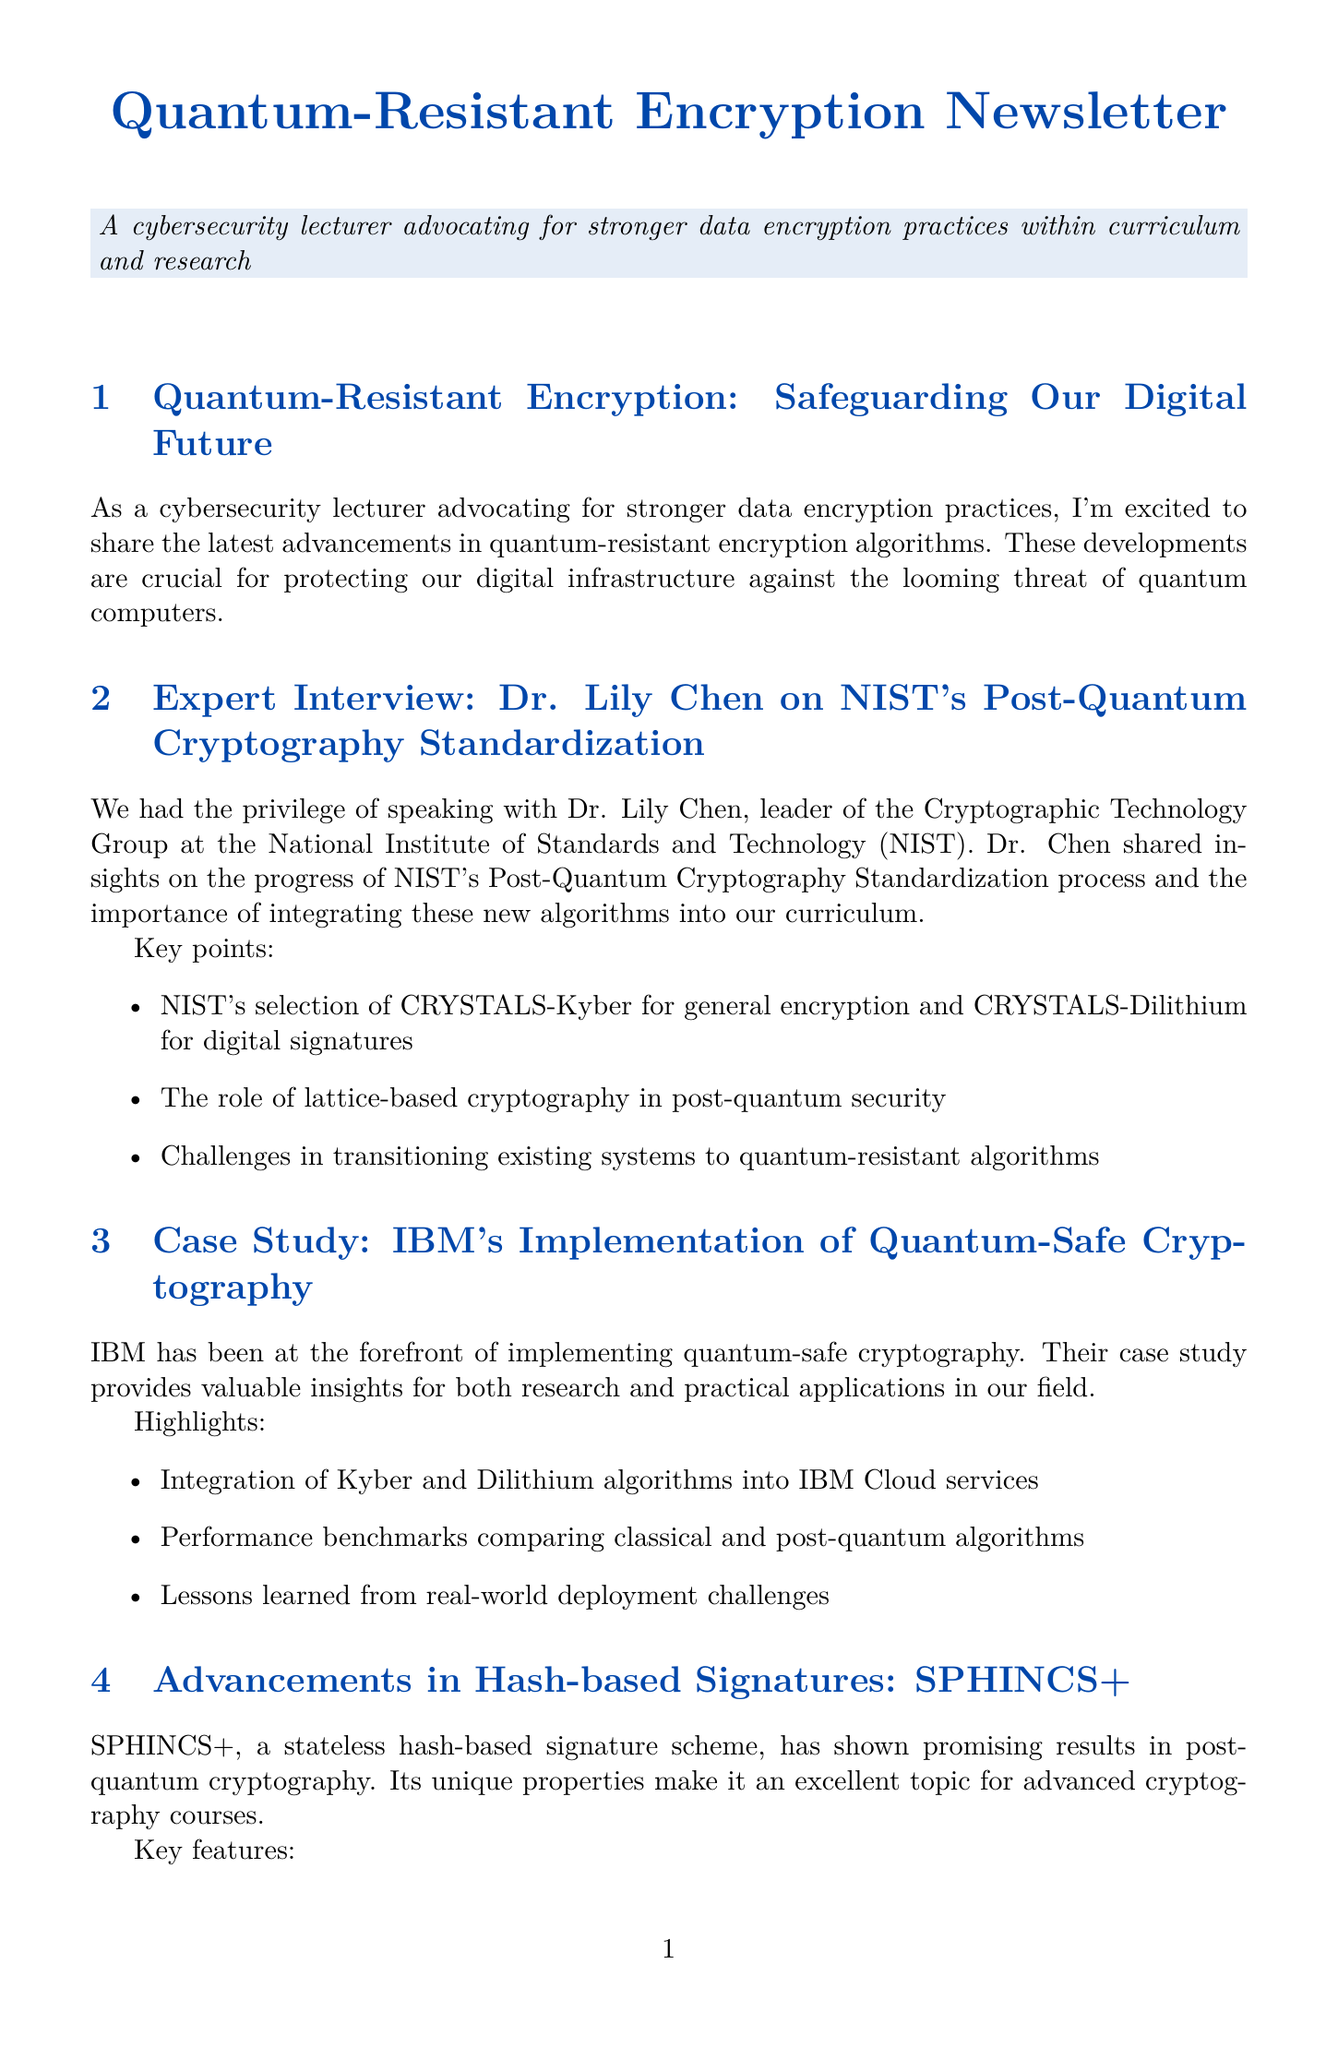What is the title of the first section? The title of the first section is explicitly stated in the document.
Answer: Quantum-Resistant Encryption: Safeguarding Our Digital Future Who is the expert interviewed in the newsletter? The interview section mentions the name of the expert who provided insights on post-quantum cryptography.
Answer: Dr. Lily Chen What algorithm did NIST select for general encryption? The document lists specific algorithms chosen by NIST for their purposes.
Answer: CRYSTALS-Kyber What is one key feature of SPHINCS+? The unique features of SPHINCS+ are summarized in the section about it.
Answer: Resistance to both classical and quantum attacks What organization is partnering with the lecturer for PQC applications? The document specifies which organization is collaborating on post-quantum cryptography applications.
Answer: Thales How many workshop topics are mentioned for the Post-Quantum Cryptography Workshop? The workshop section details the number of topics covered, which can be counted based on the listed items.
Answer: Three What is the focus of the workshop? The section about the workshop provides specific topics that explain its focus and purpose.
Answer: Implementing and analyzing quantum-resistant algorithms Which algorithm is associated with isogeny-based cryptography? The research spotlight describes a specific algorithm related to isogeny-based cryptography.
Answer: SIKE What is the role of lattice-based cryptography according to Dr. Chen? The document mentions the significance of lattice-based cryptography in the context of post-quantum security during the expert interview.
Answer: Post-quantum security 